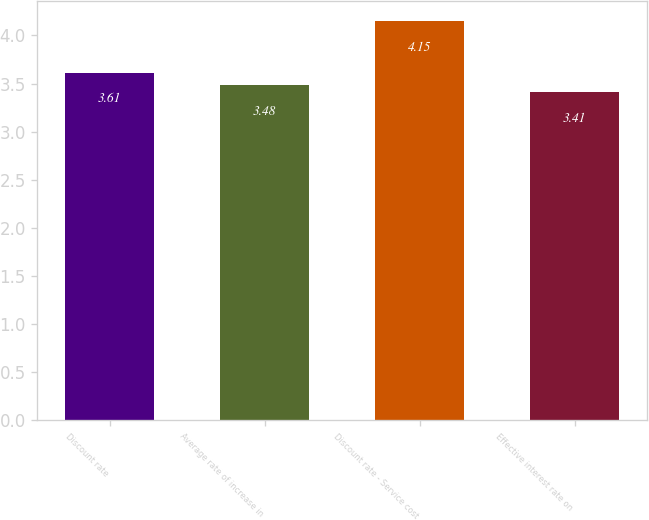Convert chart. <chart><loc_0><loc_0><loc_500><loc_500><bar_chart><fcel>Discount rate<fcel>Average rate of increase in<fcel>Discount rate - Service cost<fcel>Effective interest rate on<nl><fcel>3.61<fcel>3.48<fcel>4.15<fcel>3.41<nl></chart> 